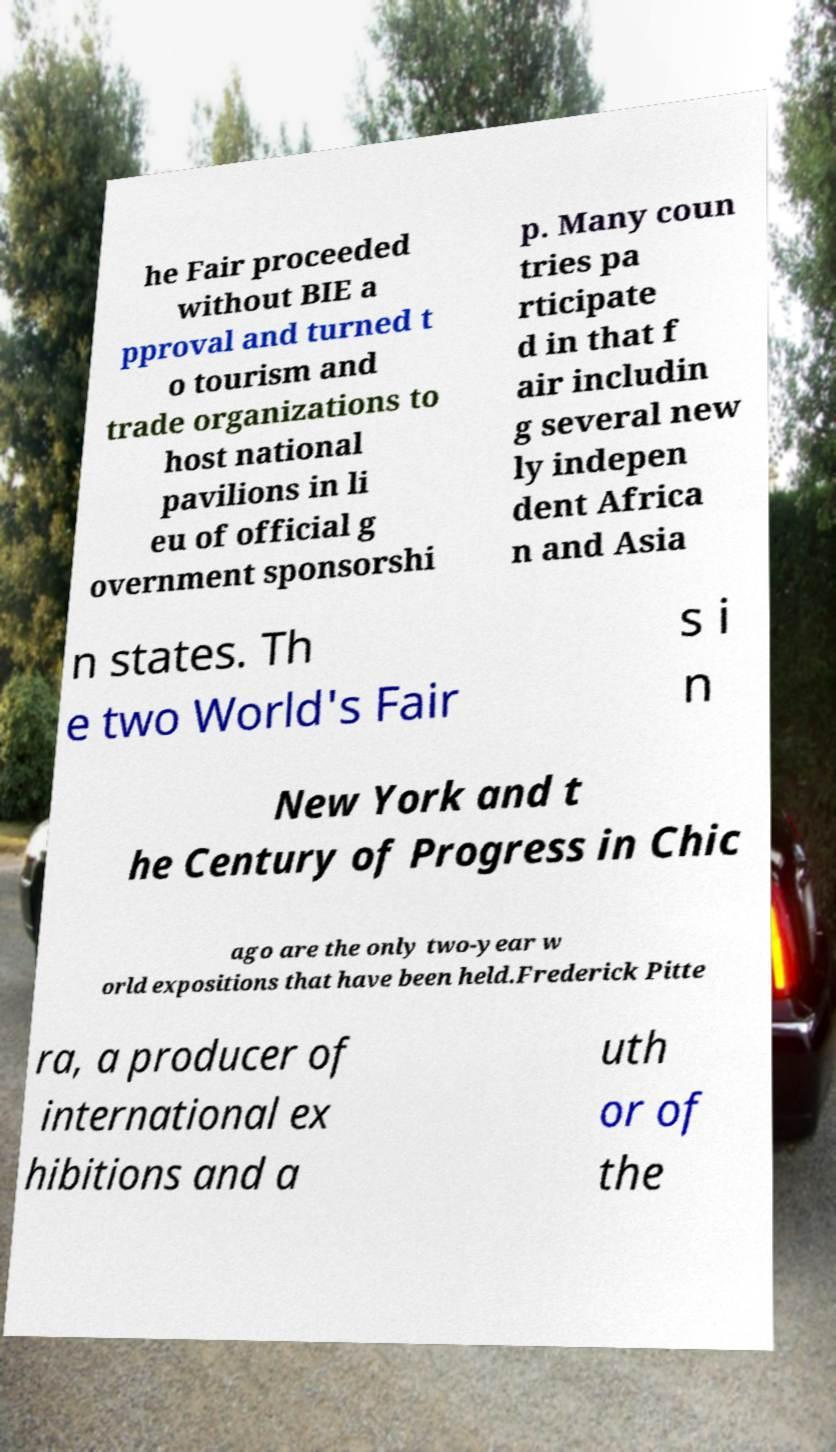There's text embedded in this image that I need extracted. Can you transcribe it verbatim? he Fair proceeded without BIE a pproval and turned t o tourism and trade organizations to host national pavilions in li eu of official g overnment sponsorshi p. Many coun tries pa rticipate d in that f air includin g several new ly indepen dent Africa n and Asia n states. Th e two World's Fair s i n New York and t he Century of Progress in Chic ago are the only two-year w orld expositions that have been held.Frederick Pitte ra, a producer of international ex hibitions and a uth or of the 